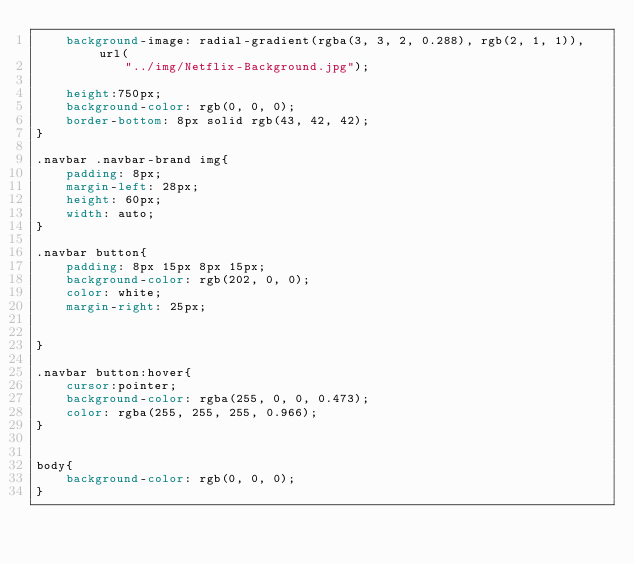<code> <loc_0><loc_0><loc_500><loc_500><_CSS_>    background-image: radial-gradient(rgba(3, 3, 2, 0.288), rgb(2, 1, 1)), url( 
            "../img/Netflix-Background.jpg"); 
      
    height:750px;
    background-color: rgb(0, 0, 0);
    border-bottom: 8px solid rgb(43, 42, 42);
}

.navbar .navbar-brand img{
    padding: 8px;
    margin-left: 28px;
    height: 60px;
    width: auto;
}

.navbar button{
    padding: 8px 15px 8px 15px;
    background-color: rgb(202, 0, 0);
    color: white;
    margin-right: 25px;
    

}

.navbar button:hover{
    cursor:pointer;
    background-color: rgba(255, 0, 0, 0.473);
    color: rgba(255, 255, 255, 0.966);
}


body{
    background-color: rgb(0, 0, 0);
}
</code> 